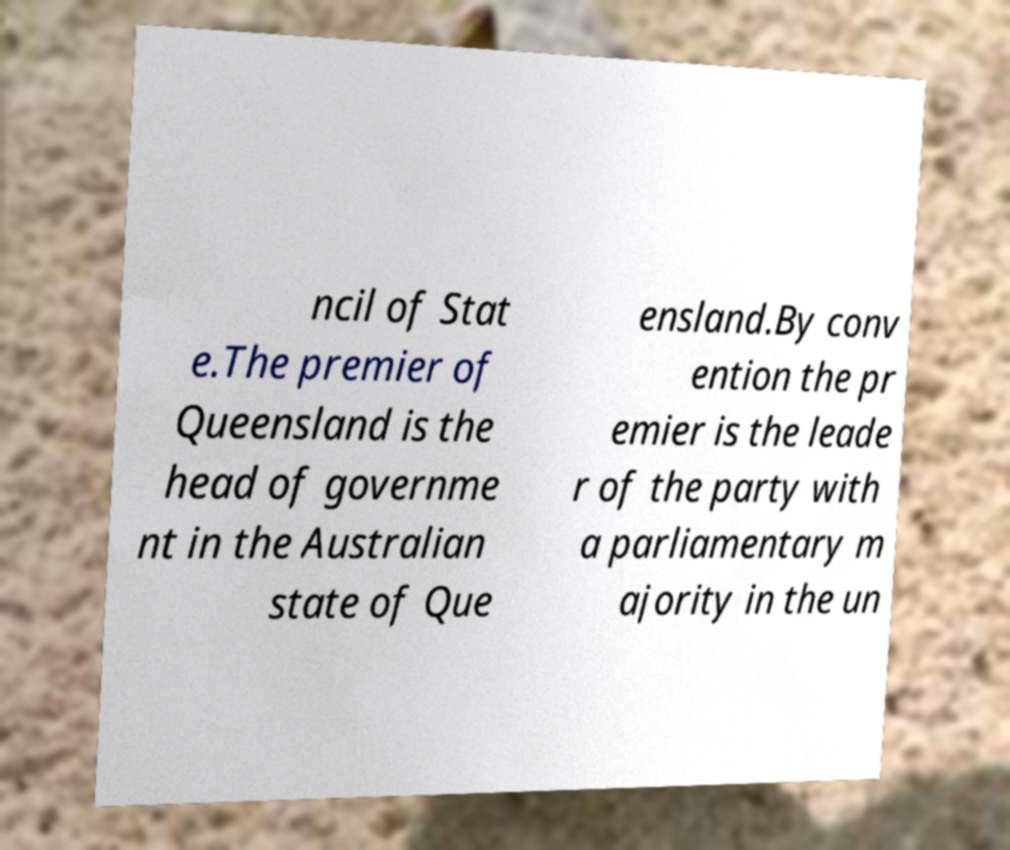Could you extract and type out the text from this image? ncil of Stat e.The premier of Queensland is the head of governme nt in the Australian state of Que ensland.By conv ention the pr emier is the leade r of the party with a parliamentary m ajority in the un 